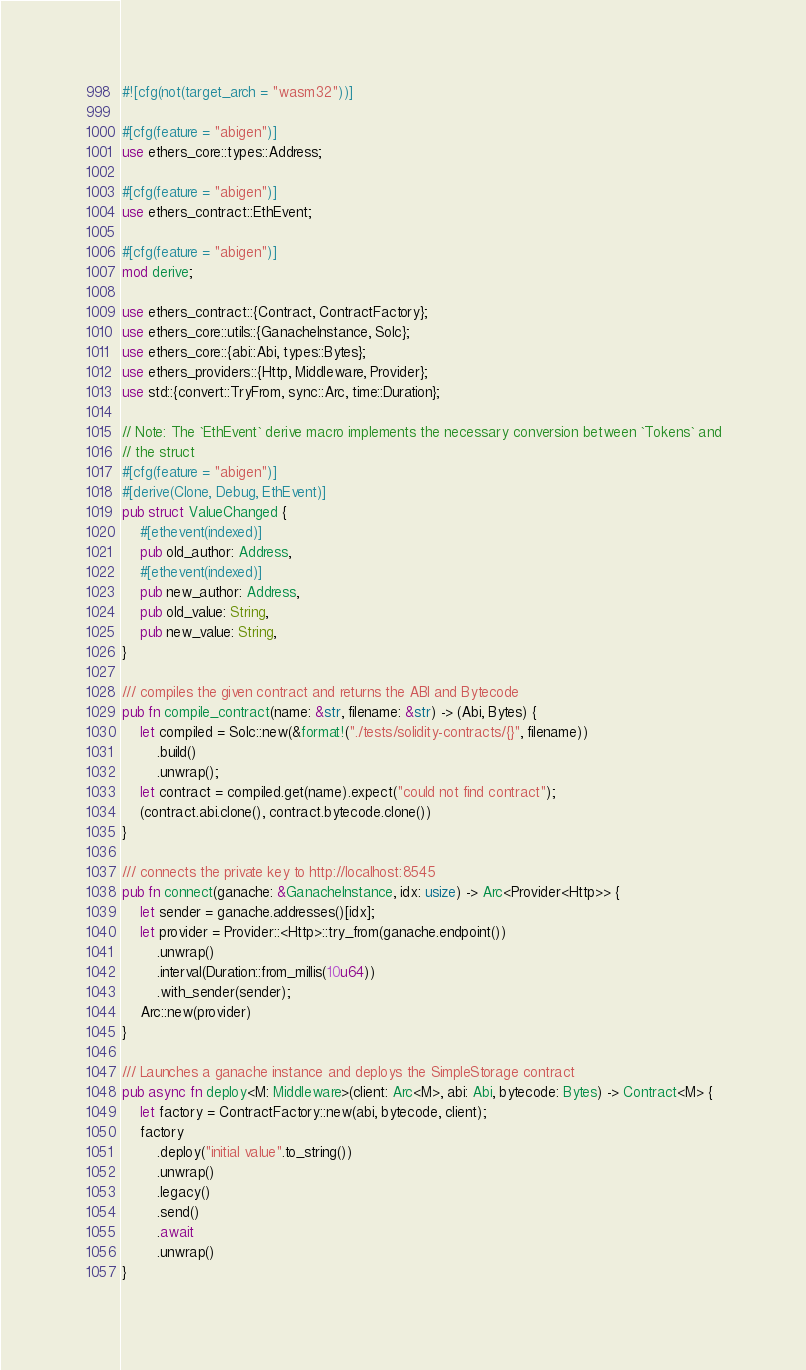<code> <loc_0><loc_0><loc_500><loc_500><_Rust_>#![cfg(not(target_arch = "wasm32"))]

#[cfg(feature = "abigen")]
use ethers_core::types::Address;

#[cfg(feature = "abigen")]
use ethers_contract::EthEvent;

#[cfg(feature = "abigen")]
mod derive;

use ethers_contract::{Contract, ContractFactory};
use ethers_core::utils::{GanacheInstance, Solc};
use ethers_core::{abi::Abi, types::Bytes};
use ethers_providers::{Http, Middleware, Provider};
use std::{convert::TryFrom, sync::Arc, time::Duration};

// Note: The `EthEvent` derive macro implements the necessary conversion between `Tokens` and
// the struct
#[cfg(feature = "abigen")]
#[derive(Clone, Debug, EthEvent)]
pub struct ValueChanged {
    #[ethevent(indexed)]
    pub old_author: Address,
    #[ethevent(indexed)]
    pub new_author: Address,
    pub old_value: String,
    pub new_value: String,
}

/// compiles the given contract and returns the ABI and Bytecode
pub fn compile_contract(name: &str, filename: &str) -> (Abi, Bytes) {
    let compiled = Solc::new(&format!("./tests/solidity-contracts/{}", filename))
        .build()
        .unwrap();
    let contract = compiled.get(name).expect("could not find contract");
    (contract.abi.clone(), contract.bytecode.clone())
}

/// connects the private key to http://localhost:8545
pub fn connect(ganache: &GanacheInstance, idx: usize) -> Arc<Provider<Http>> {
    let sender = ganache.addresses()[idx];
    let provider = Provider::<Http>::try_from(ganache.endpoint())
        .unwrap()
        .interval(Duration::from_millis(10u64))
        .with_sender(sender);
    Arc::new(provider)
}

/// Launches a ganache instance and deploys the SimpleStorage contract
pub async fn deploy<M: Middleware>(client: Arc<M>, abi: Abi, bytecode: Bytes) -> Contract<M> {
    let factory = ContractFactory::new(abi, bytecode, client);
    factory
        .deploy("initial value".to_string())
        .unwrap()
        .legacy()
        .send()
        .await
        .unwrap()
}
</code> 